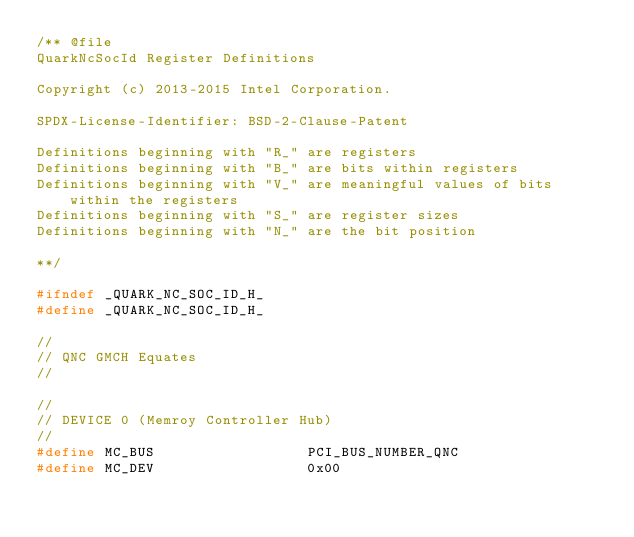<code> <loc_0><loc_0><loc_500><loc_500><_C_>/** @file
QuarkNcSocId Register Definitions

Copyright (c) 2013-2015 Intel Corporation.

SPDX-License-Identifier: BSD-2-Clause-Patent

Definitions beginning with "R_" are registers
Definitions beginning with "B_" are bits within registers
Definitions beginning with "V_" are meaningful values of bits within the registers
Definitions beginning with "S_" are register sizes
Definitions beginning with "N_" are the bit position

**/

#ifndef _QUARK_NC_SOC_ID_H_
#define _QUARK_NC_SOC_ID_H_

//
// QNC GMCH Equates
//

//
// DEVICE 0 (Memroy Controller Hub)
//
#define MC_BUS                  PCI_BUS_NUMBER_QNC
#define MC_DEV                  0x00</code> 